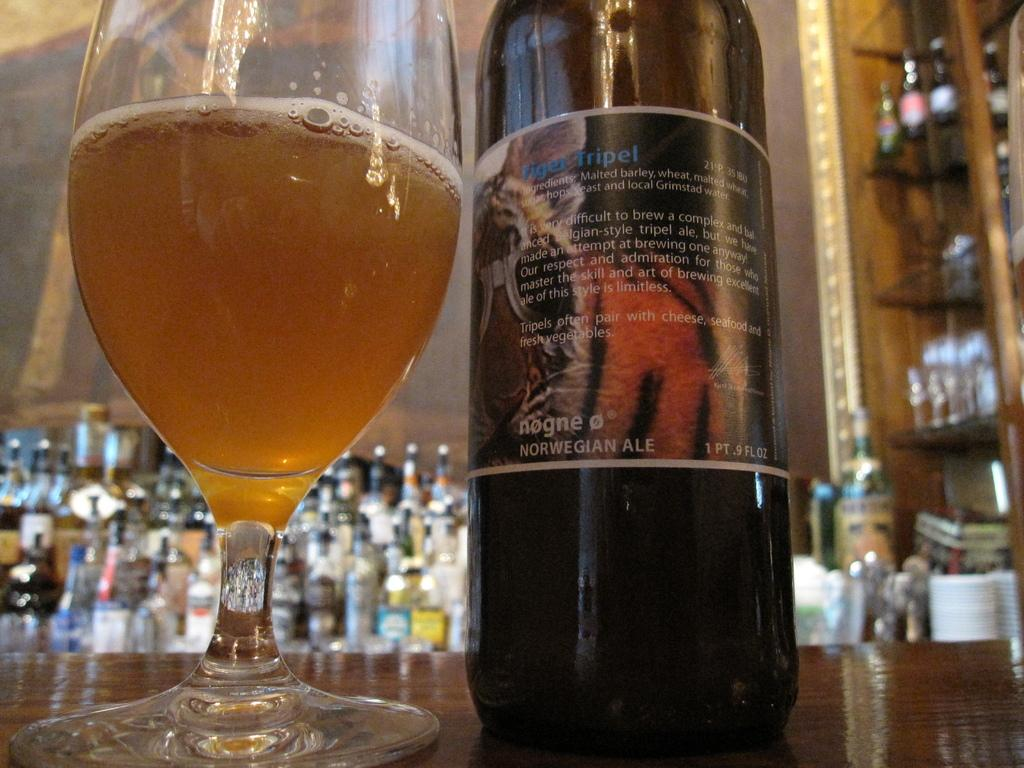<image>
Relay a brief, clear account of the picture shown. Bottle of Tiger Tripel .9 FL Oz with a glass beside it. 